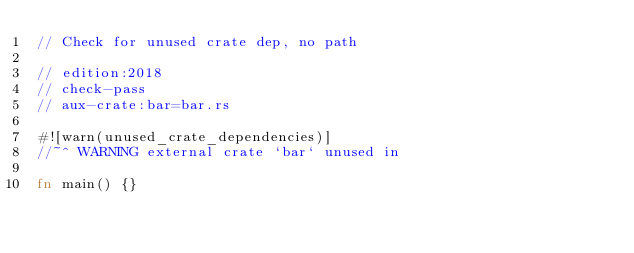Convert code to text. <code><loc_0><loc_0><loc_500><loc_500><_Rust_>// Check for unused crate dep, no path

// edition:2018
// check-pass
// aux-crate:bar=bar.rs

#![warn(unused_crate_dependencies)]
//~^ WARNING external crate `bar` unused in

fn main() {}
</code> 